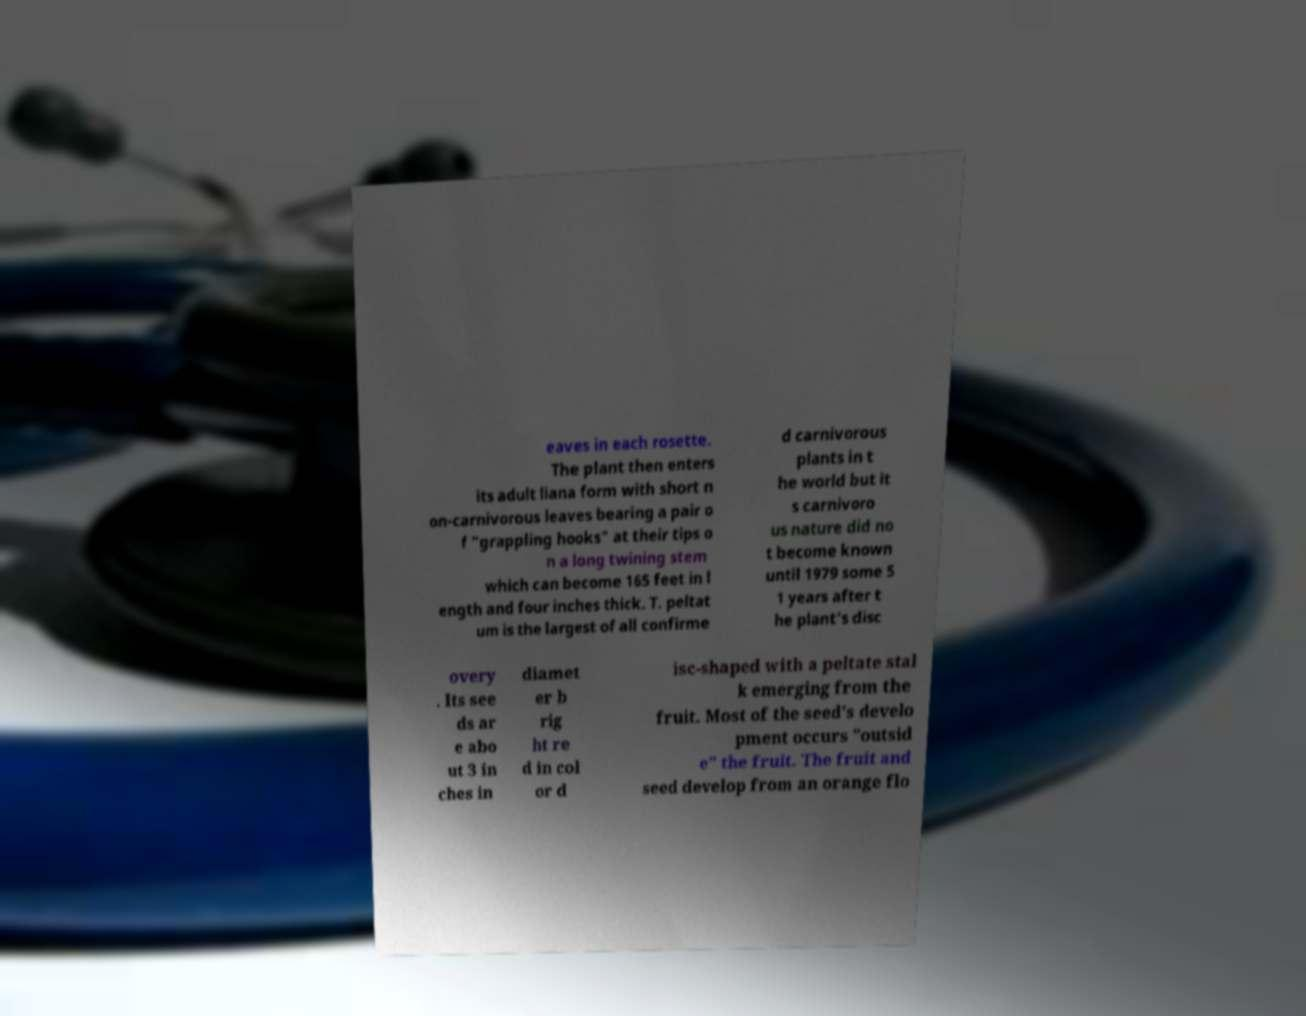What messages or text are displayed in this image? I need them in a readable, typed format. eaves in each rosette. The plant then enters its adult liana form with short n on-carnivorous leaves bearing a pair o f "grappling hooks" at their tips o n a long twining stem which can become 165 feet in l ength and four inches thick. T. peltat um is the largest of all confirme d carnivorous plants in t he world but it s carnivoro us nature did no t become known until 1979 some 5 1 years after t he plant's disc overy . Its see ds ar e abo ut 3 in ches in diamet er b rig ht re d in col or d isc-shaped with a peltate stal k emerging from the fruit. Most of the seed's develo pment occurs "outsid e" the fruit. The fruit and seed develop from an orange flo 